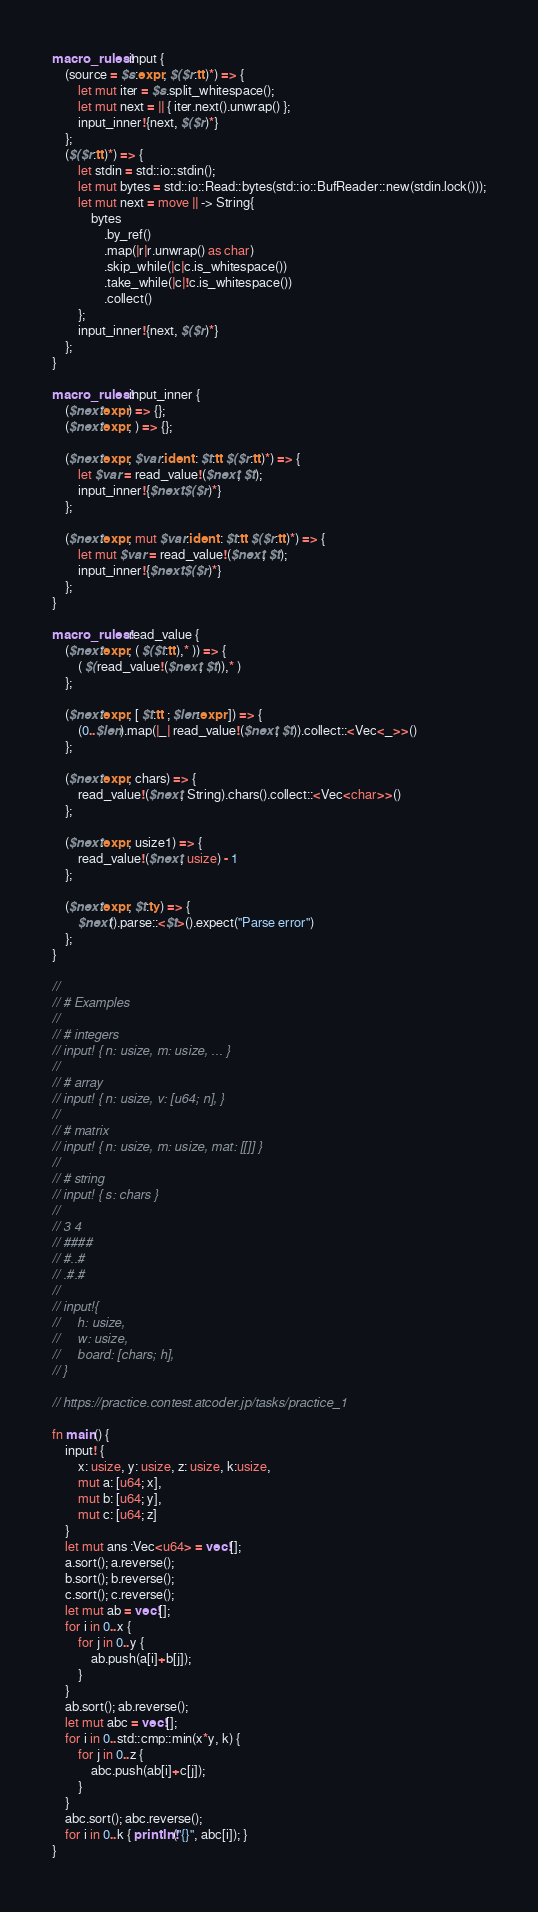Convert code to text. <code><loc_0><loc_0><loc_500><loc_500><_Rust_>macro_rules! input {
    (source = $s:expr, $($r:tt)*) => {
        let mut iter = $s.split_whitespace();
        let mut next = || { iter.next().unwrap() };
        input_inner!{next, $($r)*}
    };
    ($($r:tt)*) => {
        let stdin = std::io::stdin();
        let mut bytes = std::io::Read::bytes(std::io::BufReader::new(stdin.lock()));
        let mut next = move || -> String{
            bytes
                .by_ref()
                .map(|r|r.unwrap() as char)
                .skip_while(|c|c.is_whitespace())
                .take_while(|c|!c.is_whitespace())
                .collect()
        };
        input_inner!{next, $($r)*}
    };
}
 
macro_rules! input_inner {
    ($next:expr) => {};
    ($next:expr, ) => {};
 
    ($next:expr, $var:ident : $t:tt $($r:tt)*) => {
        let $var = read_value!($next, $t);
        input_inner!{$next $($r)*}
    };

    ($next:expr, mut $var:ident : $t:tt $($r:tt)*) => {
        let mut $var = read_value!($next, $t);
        input_inner!{$next $($r)*}
    };
}
 
macro_rules! read_value {
    ($next:expr, ( $($t:tt),* )) => {
        ( $(read_value!($next, $t)),* )
    };
 
    ($next:expr, [ $t:tt ; $len:expr ]) => {
        (0..$len).map(|_| read_value!($next, $t)).collect::<Vec<_>>()
    };
 
    ($next:expr, chars) => {
        read_value!($next, String).chars().collect::<Vec<char>>()
    };
 
    ($next:expr, usize1) => {
        read_value!($next, usize) - 1
    };
 
    ($next:expr, $t:ty) => {
        $next().parse::<$t>().expect("Parse error")
    };
}
 
//
// # Examples
//
// # integers
// input! { n: usize, m: usize, ... }
//
// # array
// input! { n: usize, v: [u64; n], }
//
// # matrix
// input! { n: usize, m: usize, mat: [[]] }
//
// # string
// input! { s: chars }
//
// 3 4
// ####
// #..#
// .#.#
//
// input!{
//     h: usize,
//     w: usize,
//     board: [chars; h],
// }
 
// https://practice.contest.atcoder.jp/tasks/practice_1

fn main() {
    input! {
        x: usize, y: usize, z: usize, k:usize,
        mut a: [u64; x], 
        mut b: [u64; y],
        mut c: [u64; z]
    }
    let mut ans :Vec<u64> = vec![];
    a.sort(); a.reverse();
    b.sort(); b.reverse();
    c.sort(); c.reverse();
    let mut ab = vec![];
    for i in 0..x {
        for j in 0..y {
            ab.push(a[i]+b[j]);
        }
    }
    ab.sort(); ab.reverse();
    let mut abc = vec![];
    for i in 0..std::cmp::min(x*y, k) {
        for j in 0..z {
            abc.push(ab[i]+c[j]); 
        }
    }
    abc.sort(); abc.reverse();
    for i in 0..k { println!("{}", abc[i]); }
}</code> 